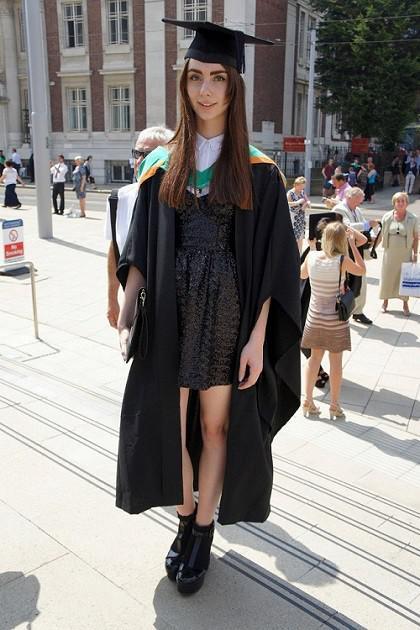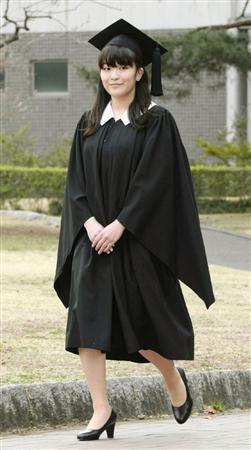The first image is the image on the left, the second image is the image on the right. For the images shown, is this caption "In each image, a woman with long dark hair is wearing a black graduation gown and mortarboard and black shoes in an outdoor setting." true? Answer yes or no. Yes. The first image is the image on the left, the second image is the image on the right. Assess this claim about the two images: "A single male is posing in graduation attire in the image on the right.". Correct or not? Answer yes or no. No. 